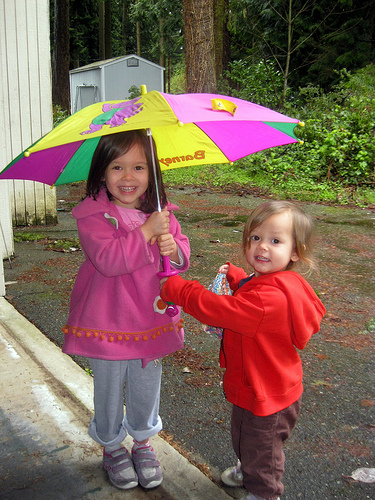What colors are on the umbrella? The umbrella has multiple colors: pink, yellow, green, blue, and a touch of purple. 